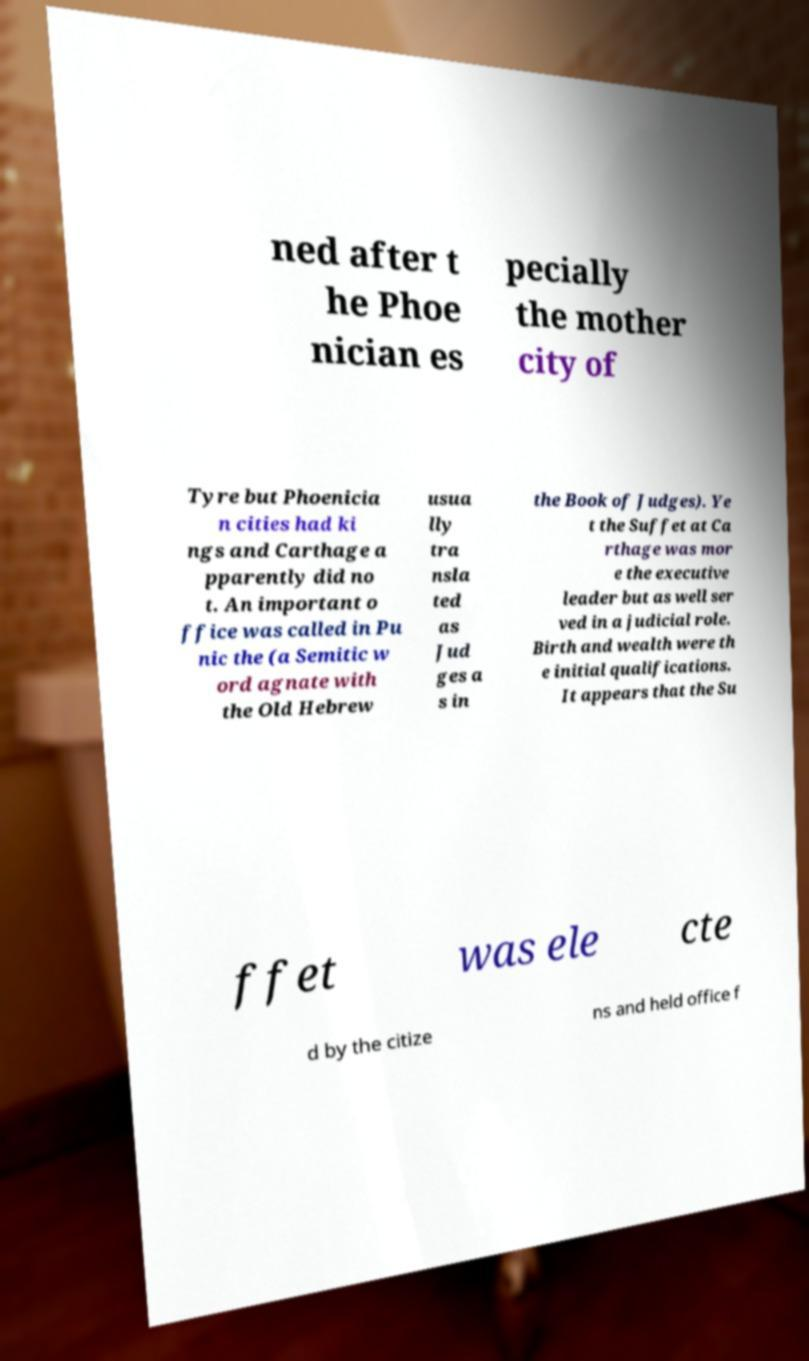I need the written content from this picture converted into text. Can you do that? ned after t he Phoe nician es pecially the mother city of Tyre but Phoenicia n cities had ki ngs and Carthage a pparently did no t. An important o ffice was called in Pu nic the (a Semitic w ord agnate with the Old Hebrew usua lly tra nsla ted as Jud ges a s in the Book of Judges). Ye t the Suffet at Ca rthage was mor e the executive leader but as well ser ved in a judicial role. Birth and wealth were th e initial qualifications. It appears that the Su ffet was ele cte d by the citize ns and held office f 